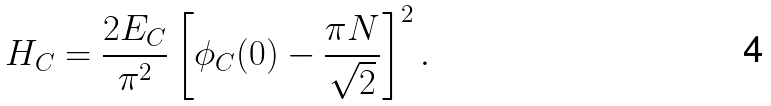<formula> <loc_0><loc_0><loc_500><loc_500>H _ { C } = \frac { 2 E _ { C } } { \pi ^ { 2 } } \left [ \phi _ { C } ( 0 ) - \frac { \pi N } { \sqrt { 2 } } \right ] ^ { 2 } .</formula> 